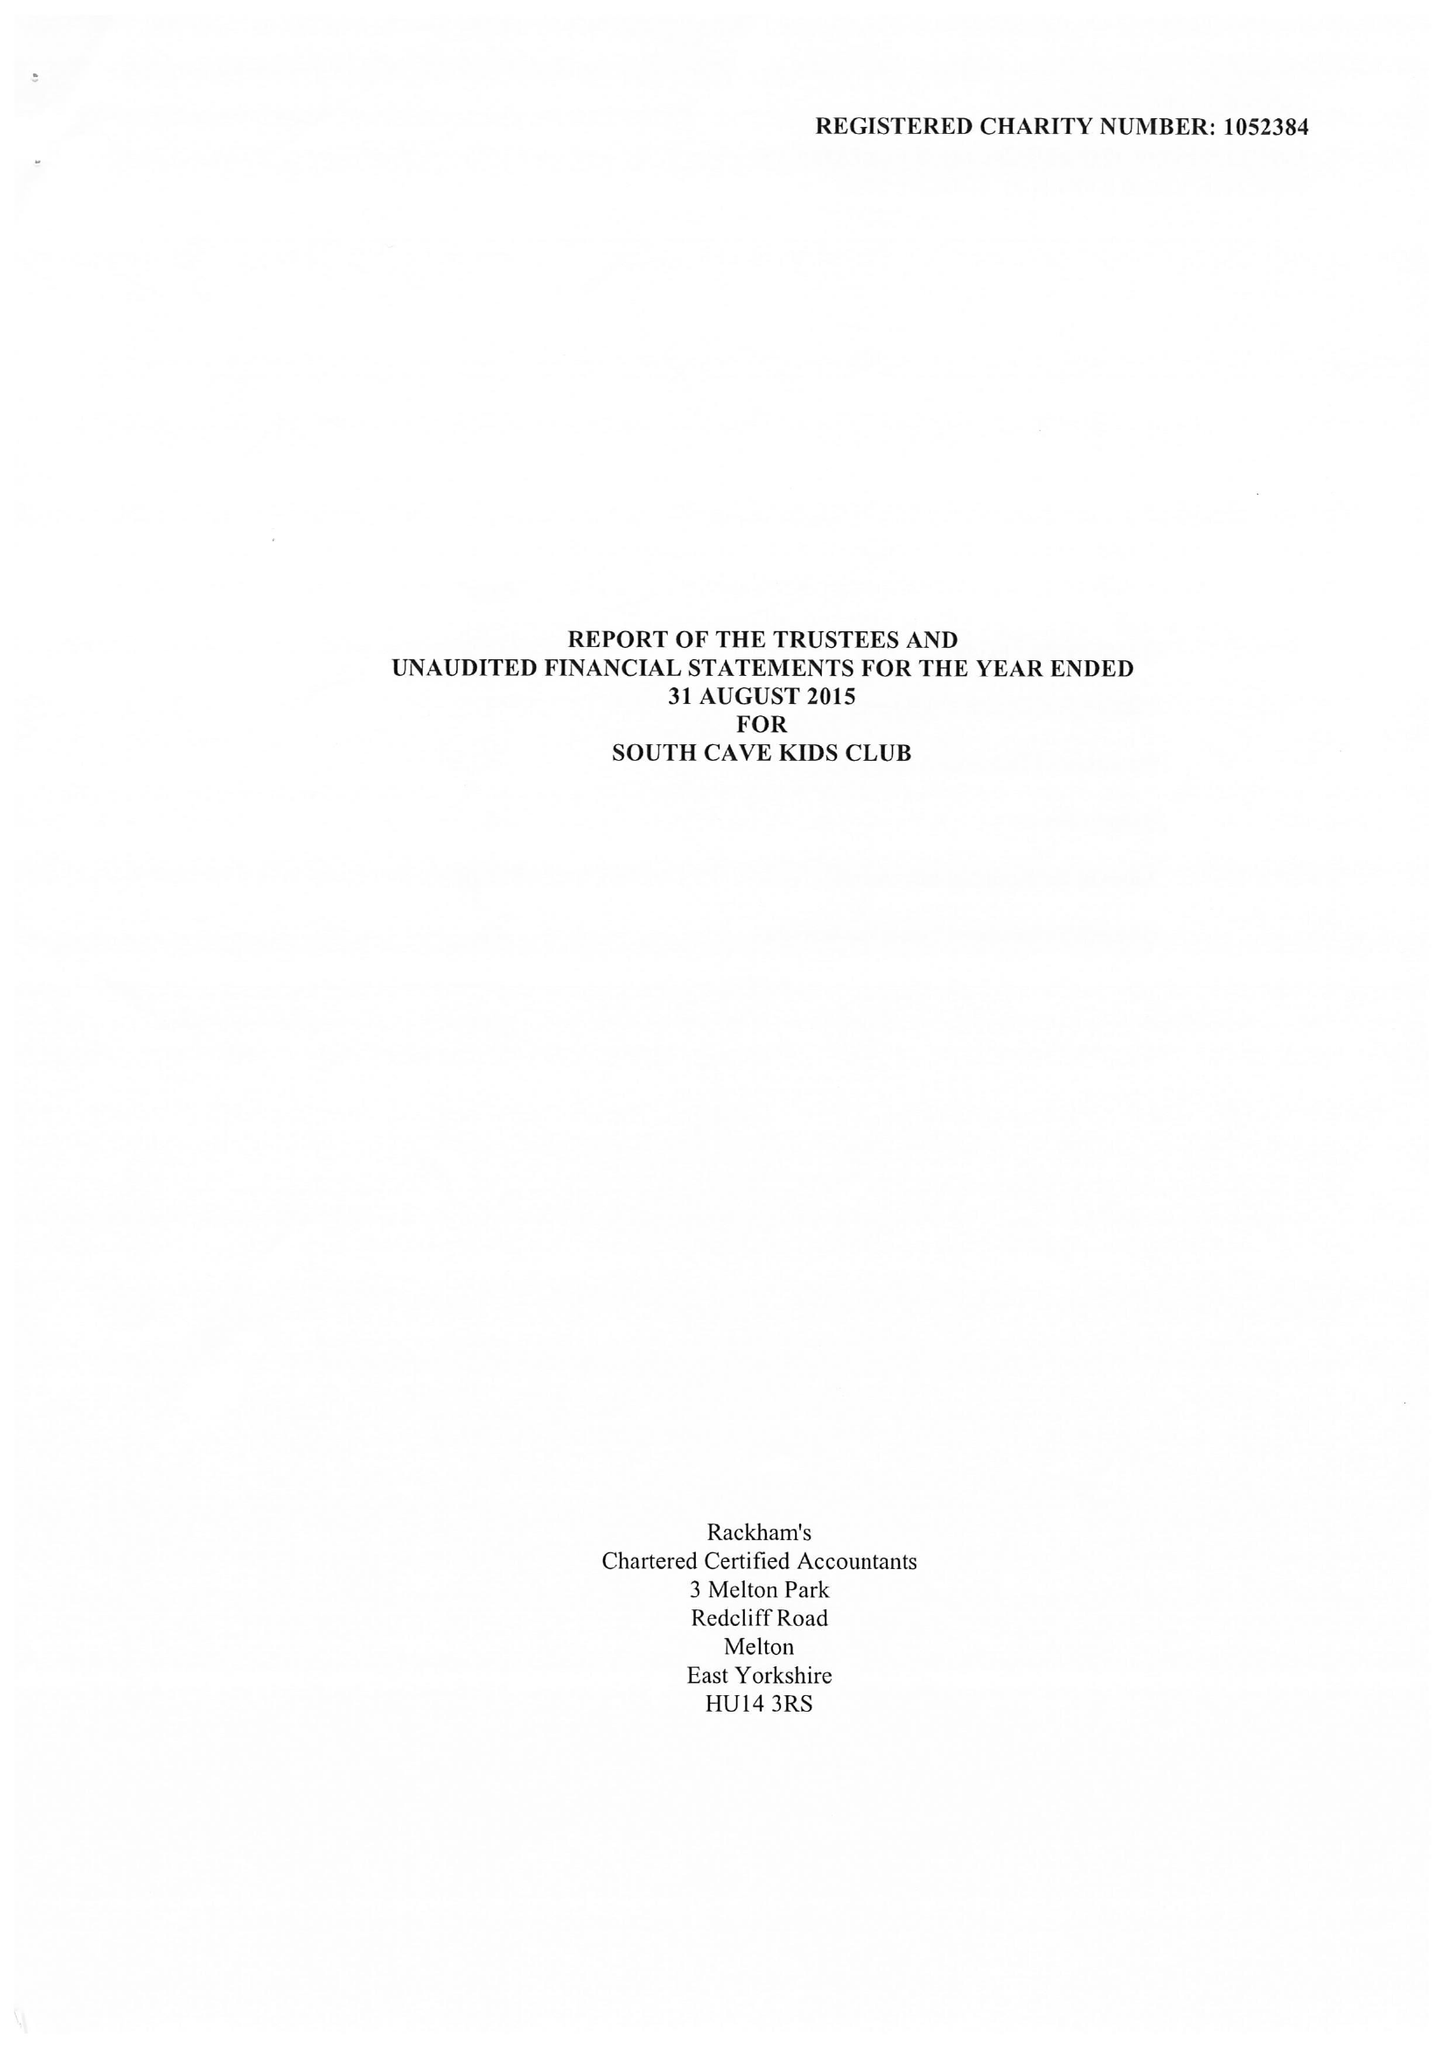What is the value for the charity_number?
Answer the question using a single word or phrase. 1052384 